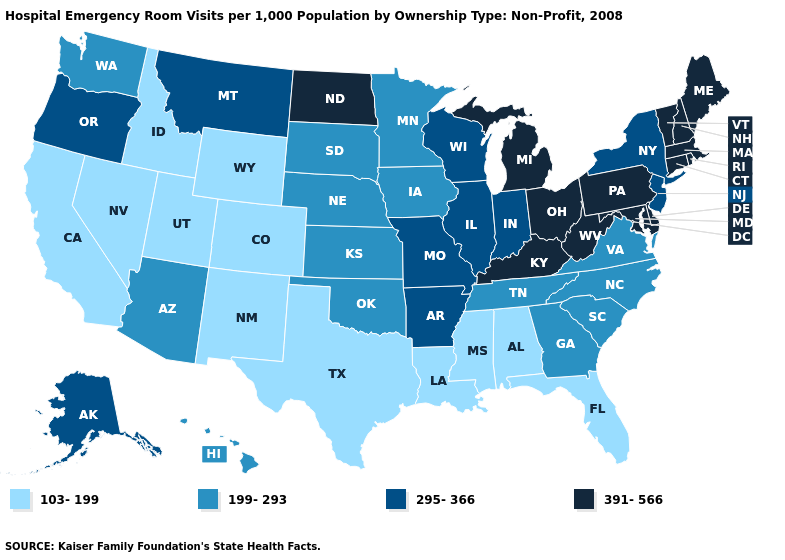What is the value of Oklahoma?
Short answer required. 199-293. Which states hav the highest value in the South?
Write a very short answer. Delaware, Kentucky, Maryland, West Virginia. What is the value of Florida?
Concise answer only. 103-199. Which states have the lowest value in the Northeast?
Keep it brief. New Jersey, New York. Among the states that border Maine , which have the highest value?
Short answer required. New Hampshire. Name the states that have a value in the range 391-566?
Be succinct. Connecticut, Delaware, Kentucky, Maine, Maryland, Massachusetts, Michigan, New Hampshire, North Dakota, Ohio, Pennsylvania, Rhode Island, Vermont, West Virginia. Name the states that have a value in the range 199-293?
Concise answer only. Arizona, Georgia, Hawaii, Iowa, Kansas, Minnesota, Nebraska, North Carolina, Oklahoma, South Carolina, South Dakota, Tennessee, Virginia, Washington. Name the states that have a value in the range 199-293?
Concise answer only. Arizona, Georgia, Hawaii, Iowa, Kansas, Minnesota, Nebraska, North Carolina, Oklahoma, South Carolina, South Dakota, Tennessee, Virginia, Washington. Name the states that have a value in the range 391-566?
Short answer required. Connecticut, Delaware, Kentucky, Maine, Maryland, Massachusetts, Michigan, New Hampshire, North Dakota, Ohio, Pennsylvania, Rhode Island, Vermont, West Virginia. Among the states that border Utah , does Nevada have the lowest value?
Answer briefly. Yes. Among the states that border Arkansas , does Missouri have the highest value?
Be succinct. Yes. What is the value of Connecticut?
Keep it brief. 391-566. Which states hav the highest value in the West?
Be succinct. Alaska, Montana, Oregon. Among the states that border California , does Oregon have the highest value?
Give a very brief answer. Yes. Does Minnesota have a lower value than Maine?
Be succinct. Yes. 